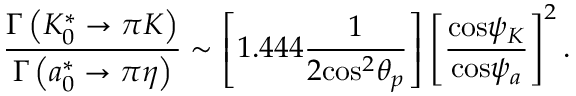Convert formula to latex. <formula><loc_0><loc_0><loc_500><loc_500>\frac { { \Gamma } \left ( K _ { 0 } ^ { * } \rightarrow \pi K \right ) } { { \Gamma } \left ( a _ { 0 } ^ { * } \rightarrow \pi \eta \right ) } \sim \left [ 1 . 4 4 4 \frac { 1 } { 2 { \cos } ^ { 2 } { \theta } _ { p } } \right ] \left [ { \frac { { \cos } { \psi } _ { K } } { { \cos } { \psi } _ { a } } } \right ] ^ { 2 } .</formula> 